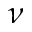<formula> <loc_0><loc_0><loc_500><loc_500>\nu</formula> 